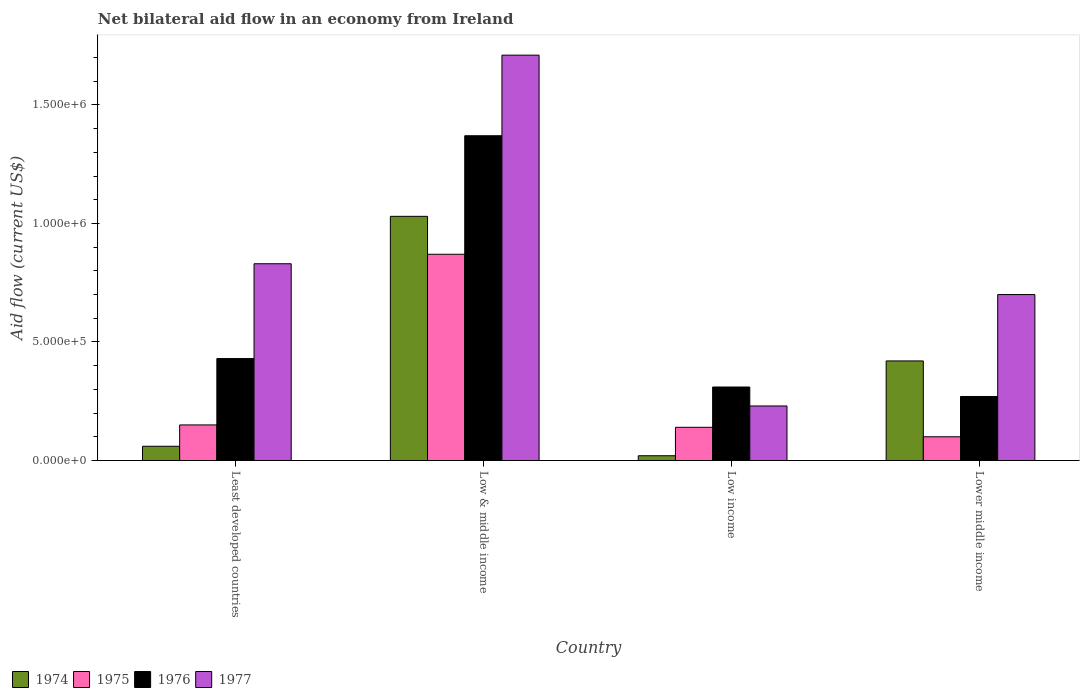Are the number of bars on each tick of the X-axis equal?
Give a very brief answer. Yes. How many bars are there on the 2nd tick from the right?
Offer a very short reply. 4. What is the label of the 4th group of bars from the left?
Make the answer very short. Lower middle income. In how many cases, is the number of bars for a given country not equal to the number of legend labels?
Make the answer very short. 0. Across all countries, what is the maximum net bilateral aid flow in 1974?
Make the answer very short. 1.03e+06. In which country was the net bilateral aid flow in 1977 maximum?
Your answer should be compact. Low & middle income. In which country was the net bilateral aid flow in 1977 minimum?
Keep it short and to the point. Low income. What is the total net bilateral aid flow in 1976 in the graph?
Your response must be concise. 2.38e+06. What is the difference between the net bilateral aid flow in 1974 in Low & middle income and that in Low income?
Your answer should be compact. 1.01e+06. What is the difference between the net bilateral aid flow in 1975 in Low & middle income and the net bilateral aid flow in 1974 in Lower middle income?
Keep it short and to the point. 4.50e+05. What is the average net bilateral aid flow in 1977 per country?
Ensure brevity in your answer.  8.68e+05. What is the difference between the net bilateral aid flow of/in 1975 and net bilateral aid flow of/in 1976 in Low & middle income?
Give a very brief answer. -5.00e+05. What is the ratio of the net bilateral aid flow in 1975 in Low & middle income to that in Low income?
Ensure brevity in your answer.  6.21. Is the net bilateral aid flow in 1975 in Low & middle income less than that in Lower middle income?
Provide a succinct answer. No. What is the difference between the highest and the second highest net bilateral aid flow in 1977?
Provide a succinct answer. 8.80e+05. What is the difference between the highest and the lowest net bilateral aid flow in 1975?
Keep it short and to the point. 7.70e+05. In how many countries, is the net bilateral aid flow in 1976 greater than the average net bilateral aid flow in 1976 taken over all countries?
Provide a short and direct response. 1. Is the sum of the net bilateral aid flow in 1975 in Low & middle income and Lower middle income greater than the maximum net bilateral aid flow in 1977 across all countries?
Keep it short and to the point. No. What does the 3rd bar from the left in Low & middle income represents?
Your answer should be very brief. 1976. What does the 3rd bar from the right in Lower middle income represents?
Keep it short and to the point. 1975. Is it the case that in every country, the sum of the net bilateral aid flow in 1977 and net bilateral aid flow in 1975 is greater than the net bilateral aid flow in 1974?
Keep it short and to the point. Yes. Are all the bars in the graph horizontal?
Provide a short and direct response. No. What is the difference between two consecutive major ticks on the Y-axis?
Keep it short and to the point. 5.00e+05. Does the graph contain any zero values?
Offer a very short reply. No. Where does the legend appear in the graph?
Offer a terse response. Bottom left. How are the legend labels stacked?
Ensure brevity in your answer.  Horizontal. What is the title of the graph?
Give a very brief answer. Net bilateral aid flow in an economy from Ireland. Does "1994" appear as one of the legend labels in the graph?
Offer a very short reply. No. What is the label or title of the X-axis?
Provide a succinct answer. Country. What is the label or title of the Y-axis?
Your response must be concise. Aid flow (current US$). What is the Aid flow (current US$) in 1976 in Least developed countries?
Give a very brief answer. 4.30e+05. What is the Aid flow (current US$) in 1977 in Least developed countries?
Provide a succinct answer. 8.30e+05. What is the Aid flow (current US$) of 1974 in Low & middle income?
Your answer should be very brief. 1.03e+06. What is the Aid flow (current US$) in 1975 in Low & middle income?
Your response must be concise. 8.70e+05. What is the Aid flow (current US$) in 1976 in Low & middle income?
Your answer should be very brief. 1.37e+06. What is the Aid flow (current US$) in 1977 in Low & middle income?
Your response must be concise. 1.71e+06. What is the Aid flow (current US$) in 1974 in Low income?
Your answer should be very brief. 2.00e+04. What is the Aid flow (current US$) in 1975 in Low income?
Offer a terse response. 1.40e+05. What is the Aid flow (current US$) in 1974 in Lower middle income?
Provide a short and direct response. 4.20e+05. What is the Aid flow (current US$) in 1976 in Lower middle income?
Offer a terse response. 2.70e+05. Across all countries, what is the maximum Aid flow (current US$) of 1974?
Provide a succinct answer. 1.03e+06. Across all countries, what is the maximum Aid flow (current US$) of 1975?
Provide a short and direct response. 8.70e+05. Across all countries, what is the maximum Aid flow (current US$) in 1976?
Keep it short and to the point. 1.37e+06. Across all countries, what is the maximum Aid flow (current US$) in 1977?
Your response must be concise. 1.71e+06. Across all countries, what is the minimum Aid flow (current US$) of 1975?
Provide a succinct answer. 1.00e+05. What is the total Aid flow (current US$) in 1974 in the graph?
Keep it short and to the point. 1.53e+06. What is the total Aid flow (current US$) of 1975 in the graph?
Your answer should be compact. 1.26e+06. What is the total Aid flow (current US$) of 1976 in the graph?
Provide a succinct answer. 2.38e+06. What is the total Aid flow (current US$) of 1977 in the graph?
Keep it short and to the point. 3.47e+06. What is the difference between the Aid flow (current US$) of 1974 in Least developed countries and that in Low & middle income?
Keep it short and to the point. -9.70e+05. What is the difference between the Aid flow (current US$) of 1975 in Least developed countries and that in Low & middle income?
Make the answer very short. -7.20e+05. What is the difference between the Aid flow (current US$) in 1976 in Least developed countries and that in Low & middle income?
Your answer should be very brief. -9.40e+05. What is the difference between the Aid flow (current US$) in 1977 in Least developed countries and that in Low & middle income?
Your answer should be very brief. -8.80e+05. What is the difference between the Aid flow (current US$) in 1974 in Least developed countries and that in Low income?
Offer a terse response. 4.00e+04. What is the difference between the Aid flow (current US$) of 1976 in Least developed countries and that in Low income?
Offer a terse response. 1.20e+05. What is the difference between the Aid flow (current US$) of 1974 in Least developed countries and that in Lower middle income?
Provide a short and direct response. -3.60e+05. What is the difference between the Aid flow (current US$) of 1976 in Least developed countries and that in Lower middle income?
Provide a succinct answer. 1.60e+05. What is the difference between the Aid flow (current US$) of 1977 in Least developed countries and that in Lower middle income?
Offer a terse response. 1.30e+05. What is the difference between the Aid flow (current US$) of 1974 in Low & middle income and that in Low income?
Make the answer very short. 1.01e+06. What is the difference between the Aid flow (current US$) in 1975 in Low & middle income and that in Low income?
Your response must be concise. 7.30e+05. What is the difference between the Aid flow (current US$) in 1976 in Low & middle income and that in Low income?
Offer a very short reply. 1.06e+06. What is the difference between the Aid flow (current US$) in 1977 in Low & middle income and that in Low income?
Keep it short and to the point. 1.48e+06. What is the difference between the Aid flow (current US$) in 1975 in Low & middle income and that in Lower middle income?
Give a very brief answer. 7.70e+05. What is the difference between the Aid flow (current US$) in 1976 in Low & middle income and that in Lower middle income?
Make the answer very short. 1.10e+06. What is the difference between the Aid flow (current US$) in 1977 in Low & middle income and that in Lower middle income?
Keep it short and to the point. 1.01e+06. What is the difference between the Aid flow (current US$) in 1974 in Low income and that in Lower middle income?
Give a very brief answer. -4.00e+05. What is the difference between the Aid flow (current US$) in 1975 in Low income and that in Lower middle income?
Offer a very short reply. 4.00e+04. What is the difference between the Aid flow (current US$) in 1976 in Low income and that in Lower middle income?
Give a very brief answer. 4.00e+04. What is the difference between the Aid flow (current US$) in 1977 in Low income and that in Lower middle income?
Offer a terse response. -4.70e+05. What is the difference between the Aid flow (current US$) in 1974 in Least developed countries and the Aid flow (current US$) in 1975 in Low & middle income?
Make the answer very short. -8.10e+05. What is the difference between the Aid flow (current US$) in 1974 in Least developed countries and the Aid flow (current US$) in 1976 in Low & middle income?
Offer a very short reply. -1.31e+06. What is the difference between the Aid flow (current US$) of 1974 in Least developed countries and the Aid flow (current US$) of 1977 in Low & middle income?
Ensure brevity in your answer.  -1.65e+06. What is the difference between the Aid flow (current US$) in 1975 in Least developed countries and the Aid flow (current US$) in 1976 in Low & middle income?
Ensure brevity in your answer.  -1.22e+06. What is the difference between the Aid flow (current US$) of 1975 in Least developed countries and the Aid flow (current US$) of 1977 in Low & middle income?
Offer a very short reply. -1.56e+06. What is the difference between the Aid flow (current US$) in 1976 in Least developed countries and the Aid flow (current US$) in 1977 in Low & middle income?
Give a very brief answer. -1.28e+06. What is the difference between the Aid flow (current US$) in 1974 in Least developed countries and the Aid flow (current US$) in 1976 in Low income?
Make the answer very short. -2.50e+05. What is the difference between the Aid flow (current US$) in 1975 in Least developed countries and the Aid flow (current US$) in 1977 in Low income?
Offer a terse response. -8.00e+04. What is the difference between the Aid flow (current US$) in 1976 in Least developed countries and the Aid flow (current US$) in 1977 in Low income?
Offer a very short reply. 2.00e+05. What is the difference between the Aid flow (current US$) of 1974 in Least developed countries and the Aid flow (current US$) of 1976 in Lower middle income?
Your response must be concise. -2.10e+05. What is the difference between the Aid flow (current US$) in 1974 in Least developed countries and the Aid flow (current US$) in 1977 in Lower middle income?
Provide a succinct answer. -6.40e+05. What is the difference between the Aid flow (current US$) in 1975 in Least developed countries and the Aid flow (current US$) in 1977 in Lower middle income?
Your answer should be very brief. -5.50e+05. What is the difference between the Aid flow (current US$) in 1974 in Low & middle income and the Aid flow (current US$) in 1975 in Low income?
Provide a short and direct response. 8.90e+05. What is the difference between the Aid flow (current US$) in 1974 in Low & middle income and the Aid flow (current US$) in 1976 in Low income?
Offer a terse response. 7.20e+05. What is the difference between the Aid flow (current US$) of 1975 in Low & middle income and the Aid flow (current US$) of 1976 in Low income?
Your response must be concise. 5.60e+05. What is the difference between the Aid flow (current US$) in 1975 in Low & middle income and the Aid flow (current US$) in 1977 in Low income?
Make the answer very short. 6.40e+05. What is the difference between the Aid flow (current US$) in 1976 in Low & middle income and the Aid flow (current US$) in 1977 in Low income?
Keep it short and to the point. 1.14e+06. What is the difference between the Aid flow (current US$) of 1974 in Low & middle income and the Aid flow (current US$) of 1975 in Lower middle income?
Keep it short and to the point. 9.30e+05. What is the difference between the Aid flow (current US$) in 1974 in Low & middle income and the Aid flow (current US$) in 1976 in Lower middle income?
Provide a short and direct response. 7.60e+05. What is the difference between the Aid flow (current US$) of 1975 in Low & middle income and the Aid flow (current US$) of 1976 in Lower middle income?
Provide a succinct answer. 6.00e+05. What is the difference between the Aid flow (current US$) in 1976 in Low & middle income and the Aid flow (current US$) in 1977 in Lower middle income?
Keep it short and to the point. 6.70e+05. What is the difference between the Aid flow (current US$) of 1974 in Low income and the Aid flow (current US$) of 1975 in Lower middle income?
Provide a short and direct response. -8.00e+04. What is the difference between the Aid flow (current US$) of 1974 in Low income and the Aid flow (current US$) of 1977 in Lower middle income?
Provide a succinct answer. -6.80e+05. What is the difference between the Aid flow (current US$) in 1975 in Low income and the Aid flow (current US$) in 1976 in Lower middle income?
Your response must be concise. -1.30e+05. What is the difference between the Aid flow (current US$) of 1975 in Low income and the Aid flow (current US$) of 1977 in Lower middle income?
Give a very brief answer. -5.60e+05. What is the difference between the Aid flow (current US$) of 1976 in Low income and the Aid flow (current US$) of 1977 in Lower middle income?
Keep it short and to the point. -3.90e+05. What is the average Aid flow (current US$) of 1974 per country?
Provide a succinct answer. 3.82e+05. What is the average Aid flow (current US$) in 1975 per country?
Provide a succinct answer. 3.15e+05. What is the average Aid flow (current US$) of 1976 per country?
Offer a terse response. 5.95e+05. What is the average Aid flow (current US$) of 1977 per country?
Keep it short and to the point. 8.68e+05. What is the difference between the Aid flow (current US$) of 1974 and Aid flow (current US$) of 1975 in Least developed countries?
Offer a terse response. -9.00e+04. What is the difference between the Aid flow (current US$) in 1974 and Aid flow (current US$) in 1976 in Least developed countries?
Keep it short and to the point. -3.70e+05. What is the difference between the Aid flow (current US$) of 1974 and Aid flow (current US$) of 1977 in Least developed countries?
Your answer should be very brief. -7.70e+05. What is the difference between the Aid flow (current US$) of 1975 and Aid flow (current US$) of 1976 in Least developed countries?
Ensure brevity in your answer.  -2.80e+05. What is the difference between the Aid flow (current US$) in 1975 and Aid flow (current US$) in 1977 in Least developed countries?
Ensure brevity in your answer.  -6.80e+05. What is the difference between the Aid flow (current US$) in 1976 and Aid flow (current US$) in 1977 in Least developed countries?
Provide a short and direct response. -4.00e+05. What is the difference between the Aid flow (current US$) in 1974 and Aid flow (current US$) in 1975 in Low & middle income?
Your answer should be compact. 1.60e+05. What is the difference between the Aid flow (current US$) of 1974 and Aid flow (current US$) of 1977 in Low & middle income?
Your response must be concise. -6.80e+05. What is the difference between the Aid flow (current US$) of 1975 and Aid flow (current US$) of 1976 in Low & middle income?
Provide a short and direct response. -5.00e+05. What is the difference between the Aid flow (current US$) of 1975 and Aid flow (current US$) of 1977 in Low & middle income?
Your answer should be very brief. -8.40e+05. What is the difference between the Aid flow (current US$) in 1974 and Aid flow (current US$) in 1975 in Low income?
Provide a succinct answer. -1.20e+05. What is the difference between the Aid flow (current US$) in 1974 and Aid flow (current US$) in 1976 in Lower middle income?
Make the answer very short. 1.50e+05. What is the difference between the Aid flow (current US$) in 1974 and Aid flow (current US$) in 1977 in Lower middle income?
Give a very brief answer. -2.80e+05. What is the difference between the Aid flow (current US$) of 1975 and Aid flow (current US$) of 1977 in Lower middle income?
Your answer should be compact. -6.00e+05. What is the difference between the Aid flow (current US$) of 1976 and Aid flow (current US$) of 1977 in Lower middle income?
Provide a succinct answer. -4.30e+05. What is the ratio of the Aid flow (current US$) in 1974 in Least developed countries to that in Low & middle income?
Your answer should be very brief. 0.06. What is the ratio of the Aid flow (current US$) of 1975 in Least developed countries to that in Low & middle income?
Your response must be concise. 0.17. What is the ratio of the Aid flow (current US$) of 1976 in Least developed countries to that in Low & middle income?
Give a very brief answer. 0.31. What is the ratio of the Aid flow (current US$) in 1977 in Least developed countries to that in Low & middle income?
Your answer should be very brief. 0.49. What is the ratio of the Aid flow (current US$) of 1974 in Least developed countries to that in Low income?
Provide a succinct answer. 3. What is the ratio of the Aid flow (current US$) of 1975 in Least developed countries to that in Low income?
Provide a short and direct response. 1.07. What is the ratio of the Aid flow (current US$) in 1976 in Least developed countries to that in Low income?
Ensure brevity in your answer.  1.39. What is the ratio of the Aid flow (current US$) in 1977 in Least developed countries to that in Low income?
Make the answer very short. 3.61. What is the ratio of the Aid flow (current US$) of 1974 in Least developed countries to that in Lower middle income?
Keep it short and to the point. 0.14. What is the ratio of the Aid flow (current US$) of 1976 in Least developed countries to that in Lower middle income?
Your answer should be very brief. 1.59. What is the ratio of the Aid flow (current US$) in 1977 in Least developed countries to that in Lower middle income?
Offer a terse response. 1.19. What is the ratio of the Aid flow (current US$) of 1974 in Low & middle income to that in Low income?
Provide a succinct answer. 51.5. What is the ratio of the Aid flow (current US$) in 1975 in Low & middle income to that in Low income?
Your response must be concise. 6.21. What is the ratio of the Aid flow (current US$) of 1976 in Low & middle income to that in Low income?
Give a very brief answer. 4.42. What is the ratio of the Aid flow (current US$) in 1977 in Low & middle income to that in Low income?
Your answer should be compact. 7.43. What is the ratio of the Aid flow (current US$) in 1974 in Low & middle income to that in Lower middle income?
Ensure brevity in your answer.  2.45. What is the ratio of the Aid flow (current US$) in 1976 in Low & middle income to that in Lower middle income?
Offer a very short reply. 5.07. What is the ratio of the Aid flow (current US$) of 1977 in Low & middle income to that in Lower middle income?
Your response must be concise. 2.44. What is the ratio of the Aid flow (current US$) of 1974 in Low income to that in Lower middle income?
Offer a very short reply. 0.05. What is the ratio of the Aid flow (current US$) in 1976 in Low income to that in Lower middle income?
Make the answer very short. 1.15. What is the ratio of the Aid flow (current US$) of 1977 in Low income to that in Lower middle income?
Provide a short and direct response. 0.33. What is the difference between the highest and the second highest Aid flow (current US$) in 1975?
Offer a terse response. 7.20e+05. What is the difference between the highest and the second highest Aid flow (current US$) of 1976?
Offer a terse response. 9.40e+05. What is the difference between the highest and the second highest Aid flow (current US$) of 1977?
Give a very brief answer. 8.80e+05. What is the difference between the highest and the lowest Aid flow (current US$) in 1974?
Give a very brief answer. 1.01e+06. What is the difference between the highest and the lowest Aid flow (current US$) in 1975?
Your answer should be compact. 7.70e+05. What is the difference between the highest and the lowest Aid flow (current US$) in 1976?
Your answer should be very brief. 1.10e+06. What is the difference between the highest and the lowest Aid flow (current US$) of 1977?
Give a very brief answer. 1.48e+06. 